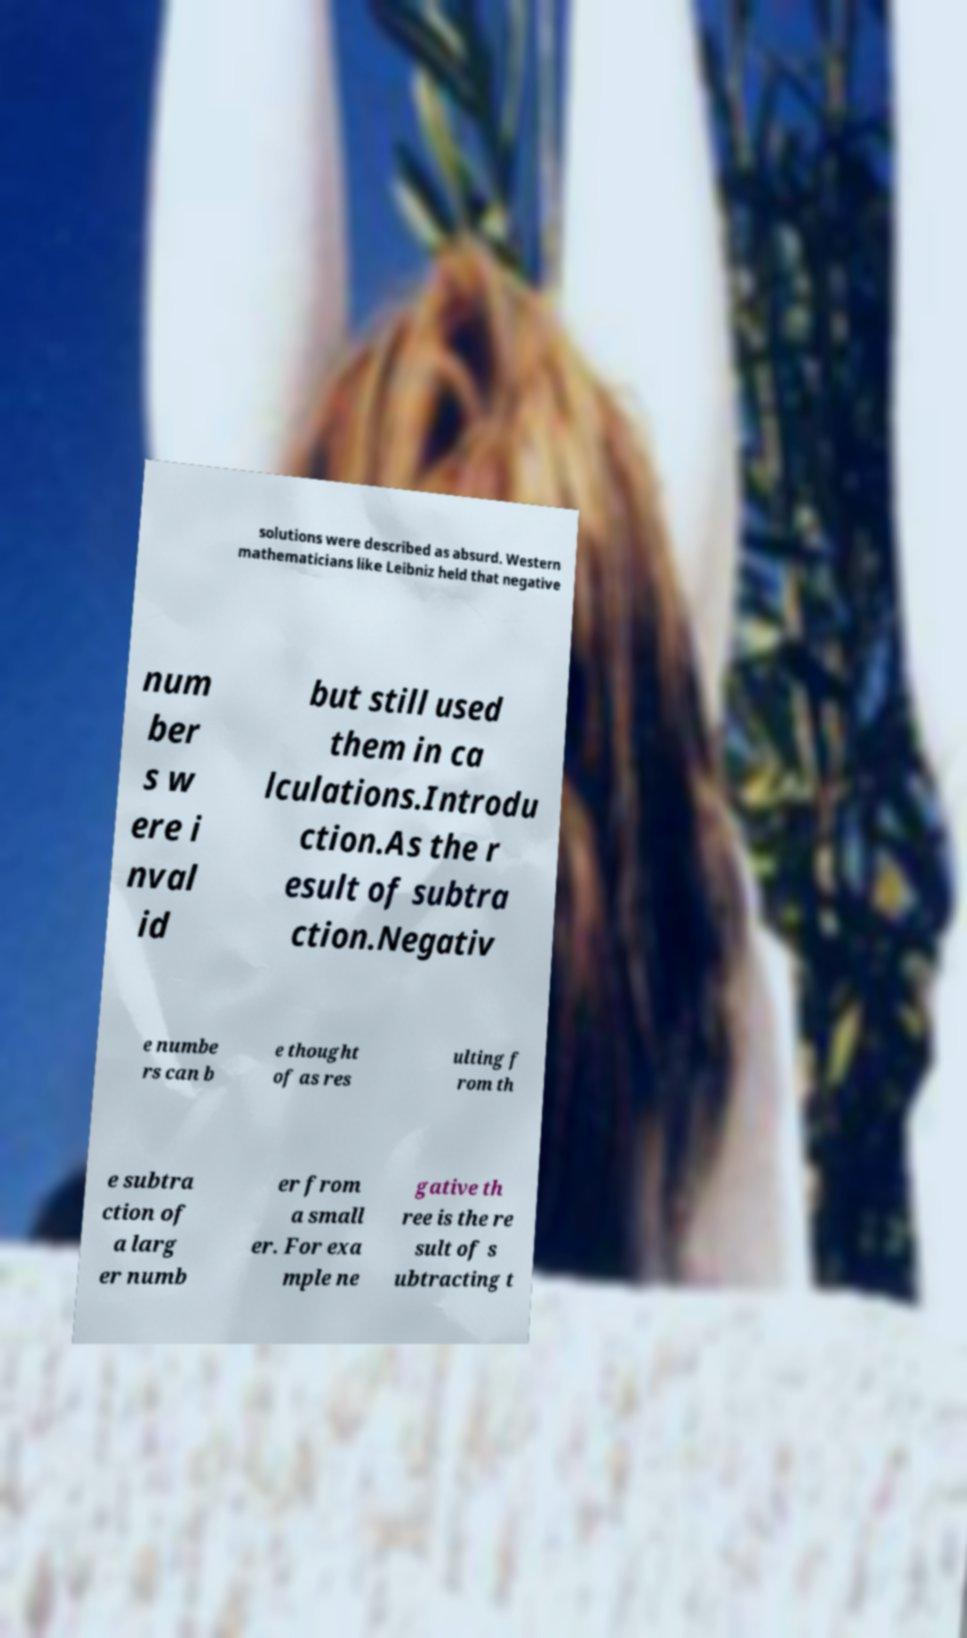Please identify and transcribe the text found in this image. solutions were described as absurd. Western mathematicians like Leibniz held that negative num ber s w ere i nval id but still used them in ca lculations.Introdu ction.As the r esult of subtra ction.Negativ e numbe rs can b e thought of as res ulting f rom th e subtra ction of a larg er numb er from a small er. For exa mple ne gative th ree is the re sult of s ubtracting t 